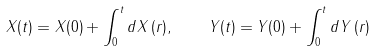Convert formula to latex. <formula><loc_0><loc_0><loc_500><loc_500>X ( t ) = X ( 0 ) + \int _ { 0 } ^ { t } d X \, ( r ) , \quad Y ( t ) = Y ( 0 ) + \int _ { 0 } ^ { t } d Y \, ( r )</formula> 